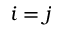<formula> <loc_0><loc_0><loc_500><loc_500>i = j</formula> 